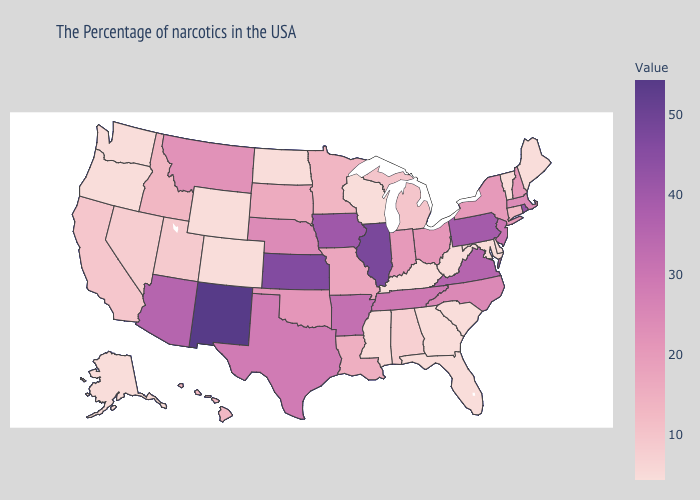Does New Mexico have the highest value in the USA?
Write a very short answer. Yes. Does North Dakota have a lower value than North Carolina?
Short answer required. Yes. Which states have the lowest value in the USA?
Quick response, please. Maine, Vermont, Delaware, Maryland, South Carolina, West Virginia, Florida, Georgia, Kentucky, Wisconsin, North Dakota, Wyoming, Colorado, Washington, Oregon, Alaska. Which states have the lowest value in the West?
Keep it brief. Wyoming, Colorado, Washington, Oregon, Alaska. Does Tennessee have the lowest value in the South?
Keep it brief. No. Does Tennessee have the highest value in the South?
Concise answer only. No. 